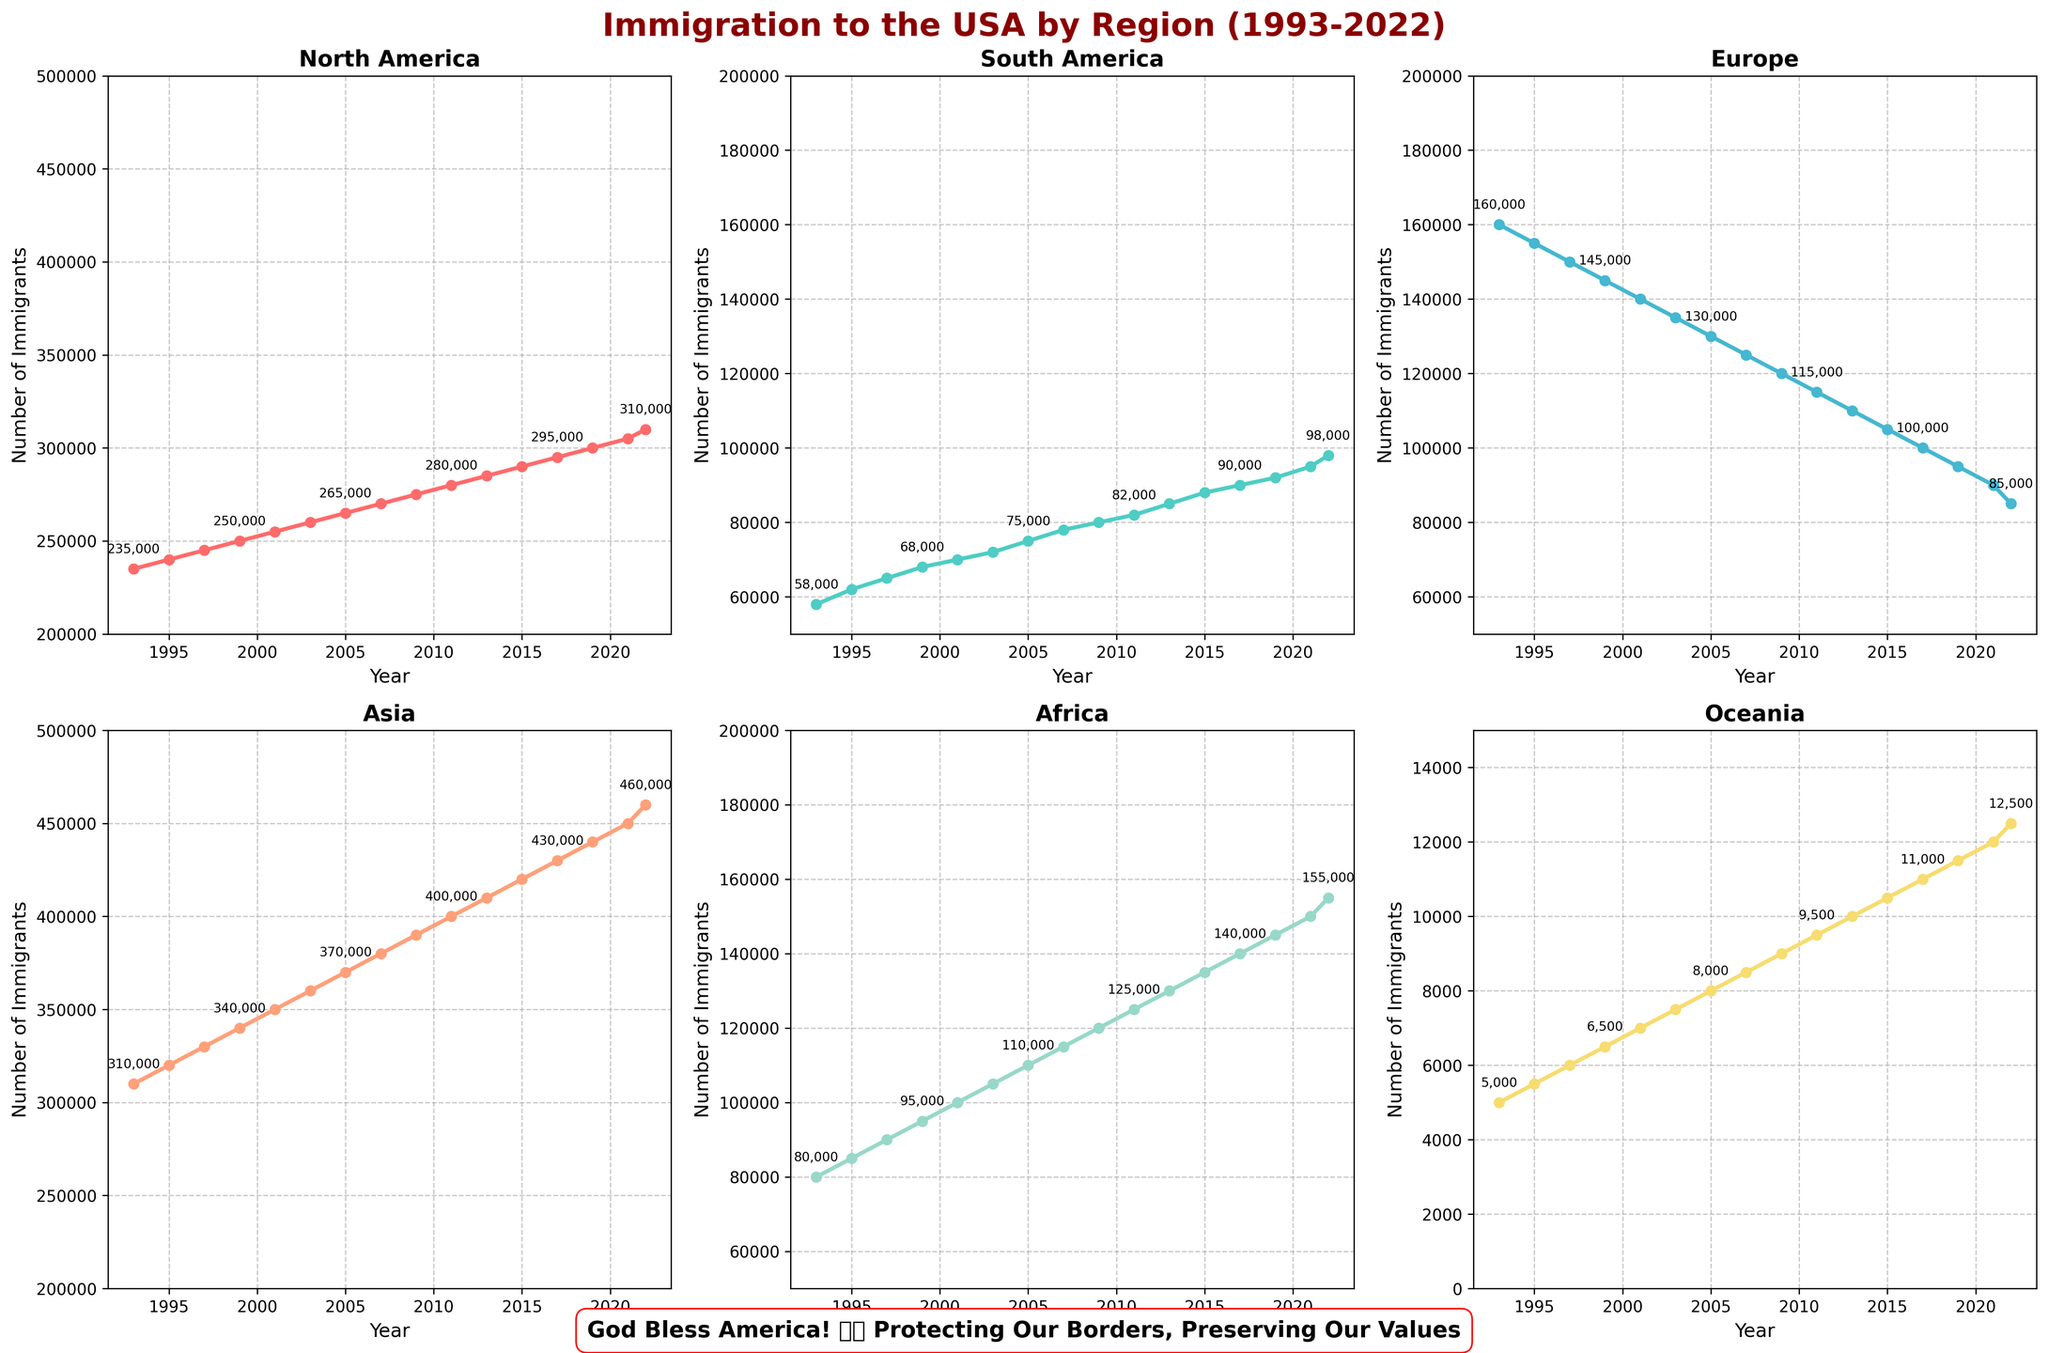What region has the highest number of immigrants in 2022? Look at the end of the timeline for 2022 and identify which line is the highest. Asia has the peak count.
Answer: Asia Which region has the most significant increase in the number of immigrants from 1993 to 2022? Calculate the difference between the number of immigrants in 2022 and 1993 for each region. Asia's increase from 310,000 to 460,000 is the largest.
Answer: Asia How did the immigration levels from Europe compare to Africa in 2011? Look at the points for 2011 for both Europe and Africa. Europe has 115,000 immigrants while Africa has 125,000.
Answer: Africa had more immigrants than Europe What's the sum of immigrants from North America and Asia in the year 2003? Add the number of immigrants from North America (260,000) and Asia (360,000) in 2003.
Answer: 620,000 Which region had the least number of immigrants in 1993, and how many were there? Look at the points for 1993 and identify which region has the lowest value. Oceania had the least, with 5,000 immigrants.
Answer: Oceania, 5,000 By what percentage did immigration from South America increase from 1995 to 2022? Calculate the percentage increase: \(\frac{(98,000 - 62,000)}{62,000} \times 100\%\).
Answer: 58.06% What's the average number of immigrants from Oceania across the entire period? Sum all values of Oceania from 1993 to 2022 and divide by the number of data points (16).
Answer: 9,062.5 Is there any year where the number of immigrants from Europe is equal to the number of immigrants from South America? Check the lines for Europe and South America in the plot to see if they match at any year. They are never equal.
Answer: No When comparing the number of immigrants across regions, which region showed no change at all from one year to the next within the timeline? North America shows a consistent increase and never stays constant year over year. Other regions also do not show a year with no change.
Answer: None 